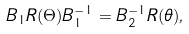<formula> <loc_0><loc_0><loc_500><loc_500>B _ { 1 } R ( \Theta ) B _ { 1 } ^ { - 1 } = B _ { 2 } ^ { - 1 } R ( \theta ) ,</formula> 